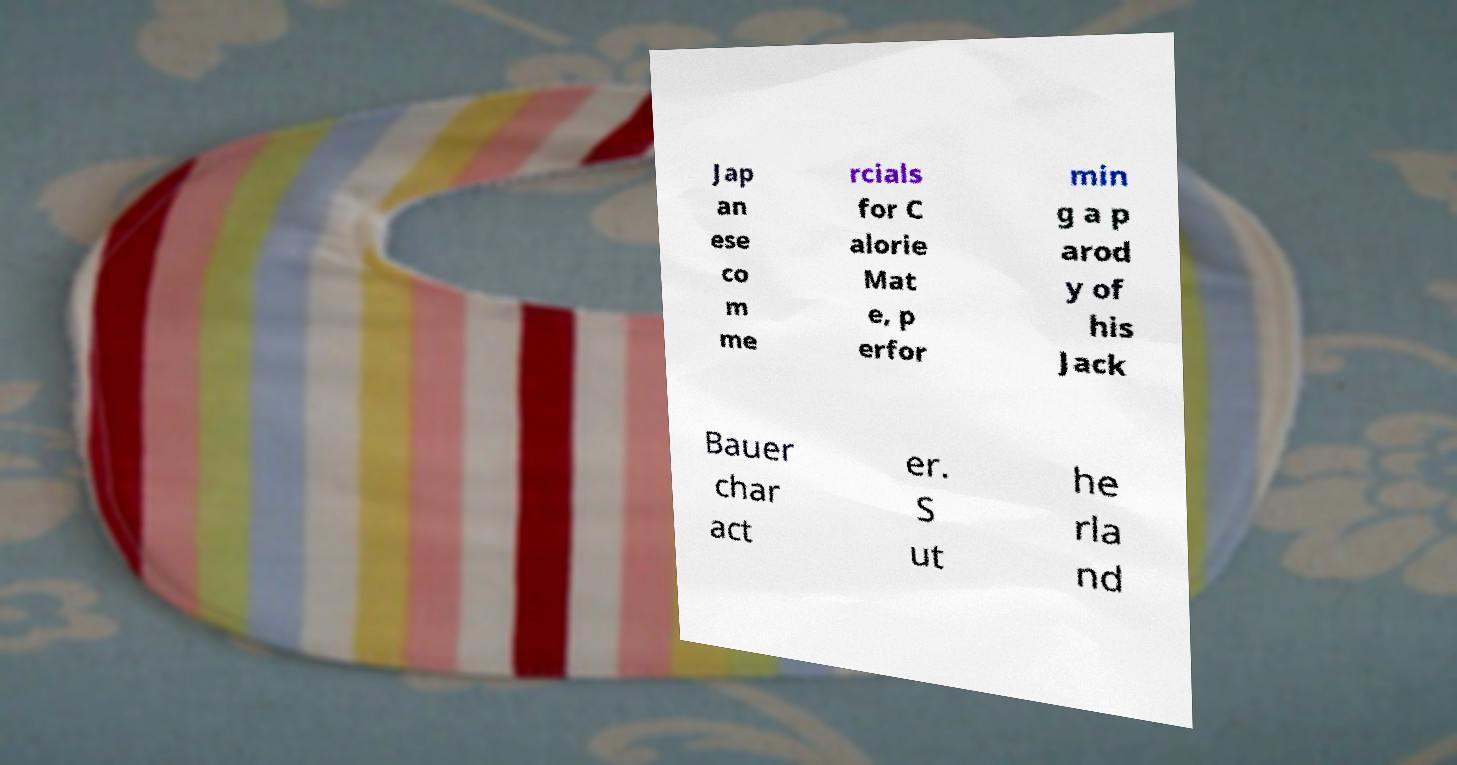Can you accurately transcribe the text from the provided image for me? Jap an ese co m me rcials for C alorie Mat e, p erfor min g a p arod y of his Jack Bauer char act er. S ut he rla nd 